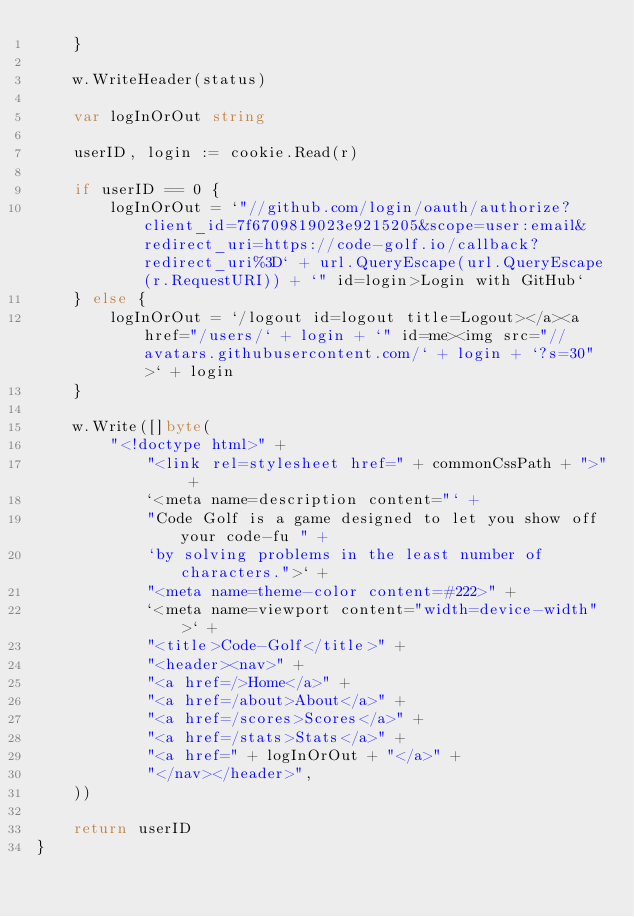Convert code to text. <code><loc_0><loc_0><loc_500><loc_500><_Go_>	}

	w.WriteHeader(status)

	var logInOrOut string

	userID, login := cookie.Read(r)

	if userID == 0 {
		logInOrOut = `"//github.com/login/oauth/authorize?client_id=7f6709819023e9215205&scope=user:email&redirect_uri=https://code-golf.io/callback?redirect_uri%3D` + url.QueryEscape(url.QueryEscape(r.RequestURI)) + `" id=login>Login with GitHub`
	} else {
		logInOrOut = `/logout id=logout title=Logout></a><a href="/users/` + login + `" id=me><img src="//avatars.githubusercontent.com/` + login + `?s=30">` + login
	}

	w.Write([]byte(
		"<!doctype html>" +
			"<link rel=stylesheet href=" + commonCssPath + ">" +
			`<meta name=description content="` +
			"Code Golf is a game designed to let you show off your code-fu " +
			`by solving problems in the least number of characters.">` +
			"<meta name=theme-color content=#222>" +
			`<meta name=viewport content="width=device-width">` +
			"<title>Code-Golf</title>" +
			"<header><nav>" +
			"<a href=/>Home</a>" +
			"<a href=/about>About</a>" +
			"<a href=/scores>Scores</a>" +
			"<a href=/stats>Stats</a>" +
			"<a href=" + logInOrOut + "</a>" +
			"</nav></header>",
	))

	return userID
}
</code> 